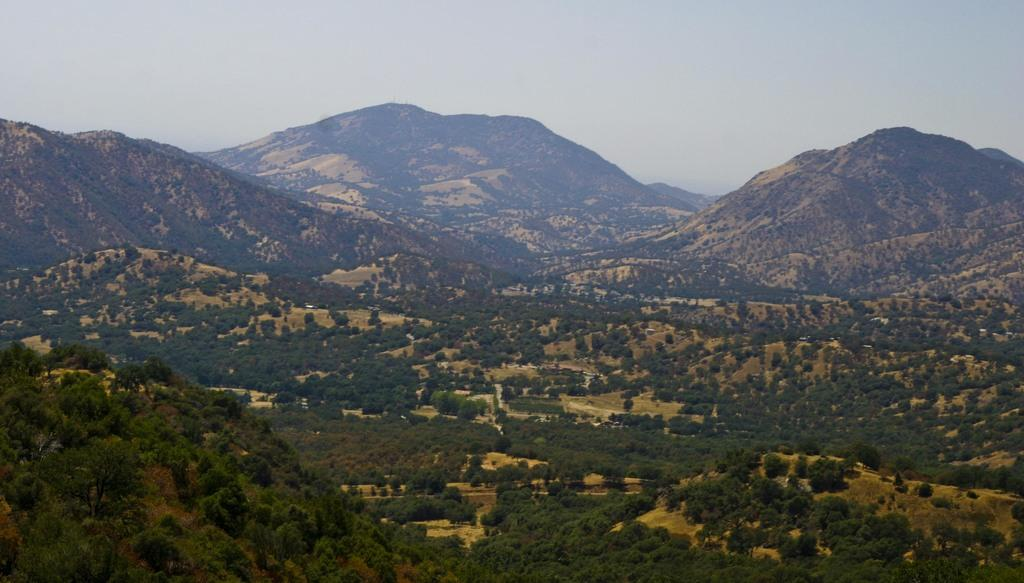What type of natural landform can be seen in the image? There are mountains in the image. What type of vegetation is present in the image? There are trees in the image. What part of the natural environment is visible in the image? The sky is visible in the image. What type of copper material can be seen in the image? There is no copper material present in the image. What expertise is required to climb the mountains in the image? The image does not provide information about the difficulty of climbing the mountains or the expertise required to do so. 